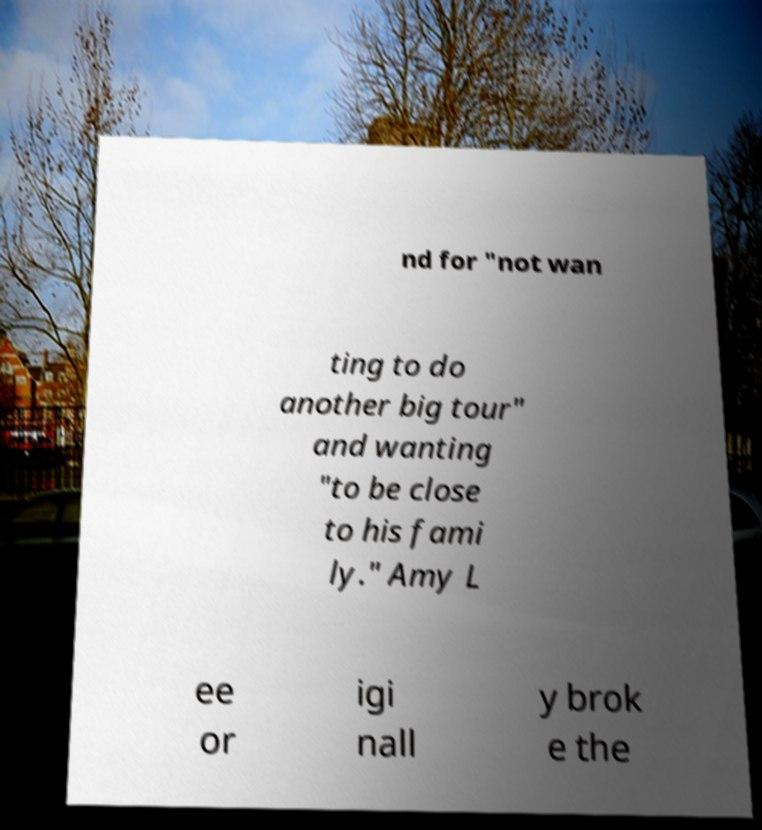Could you extract and type out the text from this image? nd for "not wan ting to do another big tour" and wanting "to be close to his fami ly." Amy L ee or igi nall y brok e the 